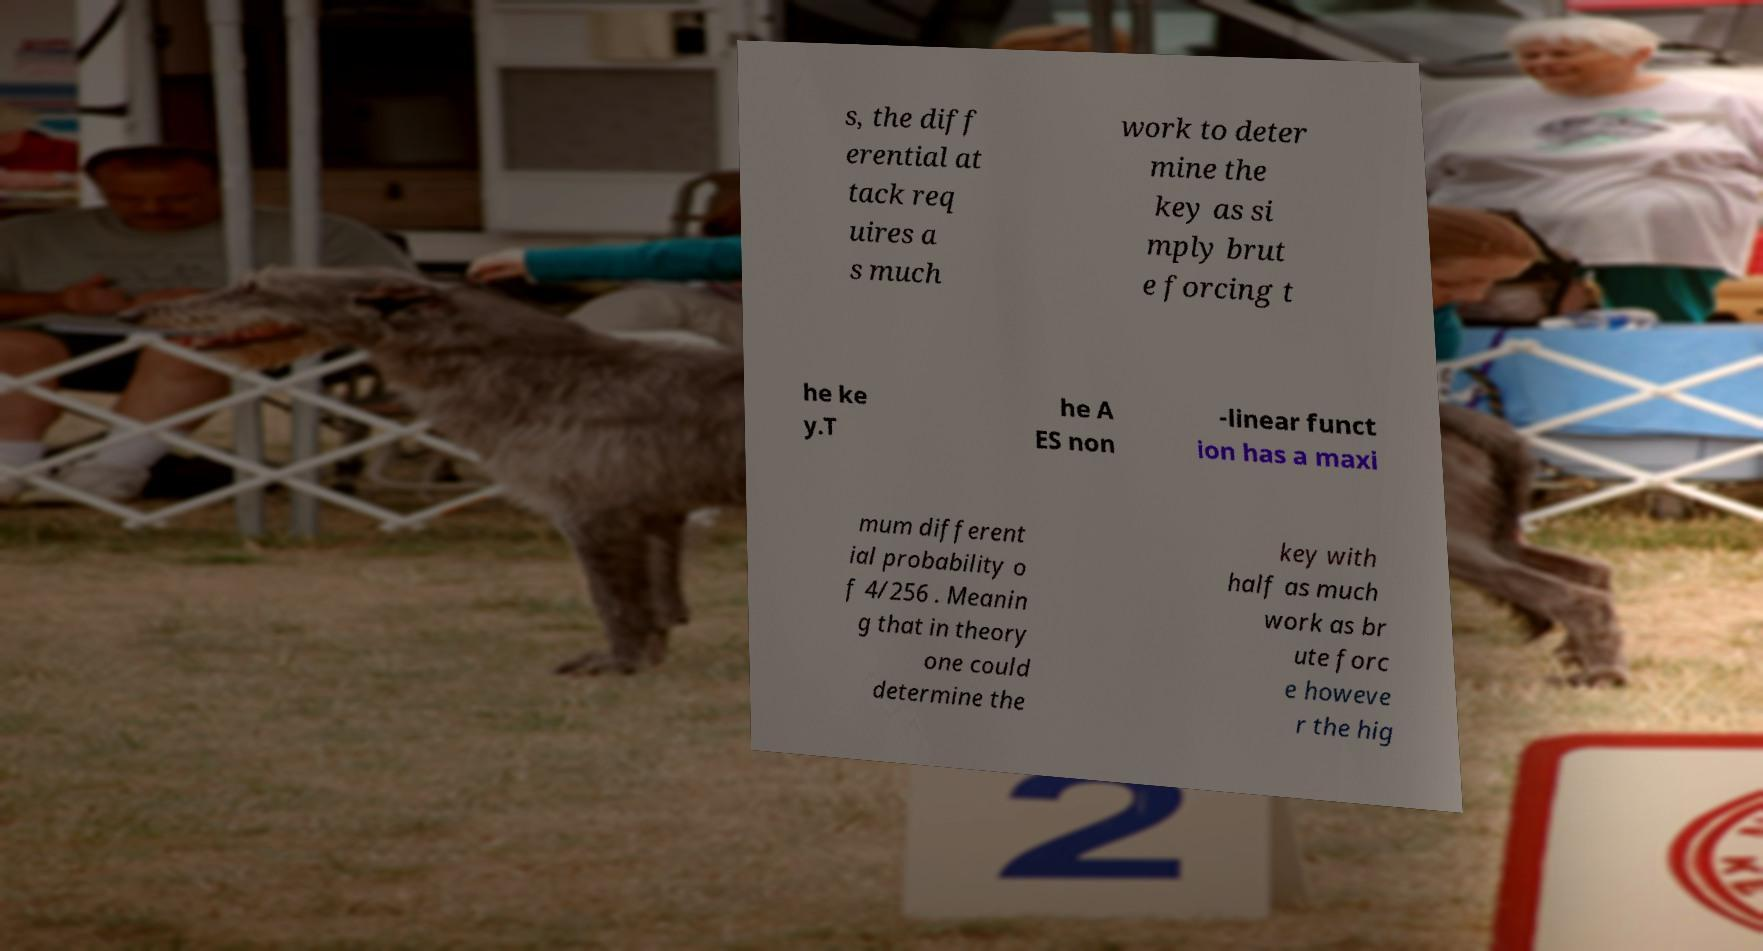Please read and relay the text visible in this image. What does it say? s, the diff erential at tack req uires a s much work to deter mine the key as si mply brut e forcing t he ke y.T he A ES non -linear funct ion has a maxi mum different ial probability o f 4/256 . Meanin g that in theory one could determine the key with half as much work as br ute forc e howeve r the hig 